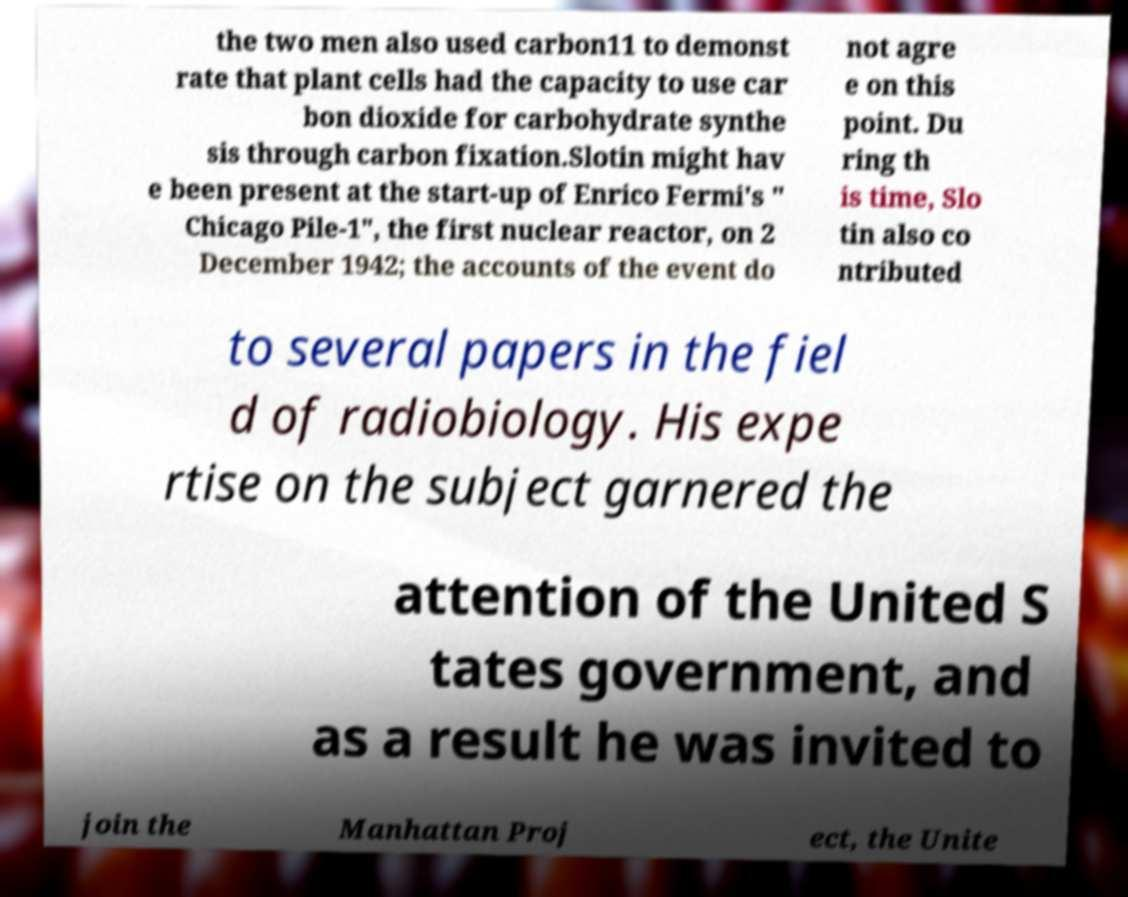Please identify and transcribe the text found in this image. the two men also used carbon11 to demonst rate that plant cells had the capacity to use car bon dioxide for carbohydrate synthe sis through carbon fixation.Slotin might hav e been present at the start-up of Enrico Fermi's " Chicago Pile-1", the first nuclear reactor, on 2 December 1942; the accounts of the event do not agre e on this point. Du ring th is time, Slo tin also co ntributed to several papers in the fiel d of radiobiology. His expe rtise on the subject garnered the attention of the United S tates government, and as a result he was invited to join the Manhattan Proj ect, the Unite 